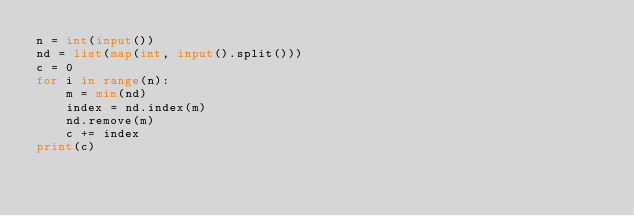Convert code to text. <code><loc_0><loc_0><loc_500><loc_500><_Python_>n = int(input())
nd = list(map(int, input().split()))
c = 0
for i in range(n):
    m = min(nd)
    index = nd.index(m)
    nd.remove(m)
    c += index
print(c)
</code> 